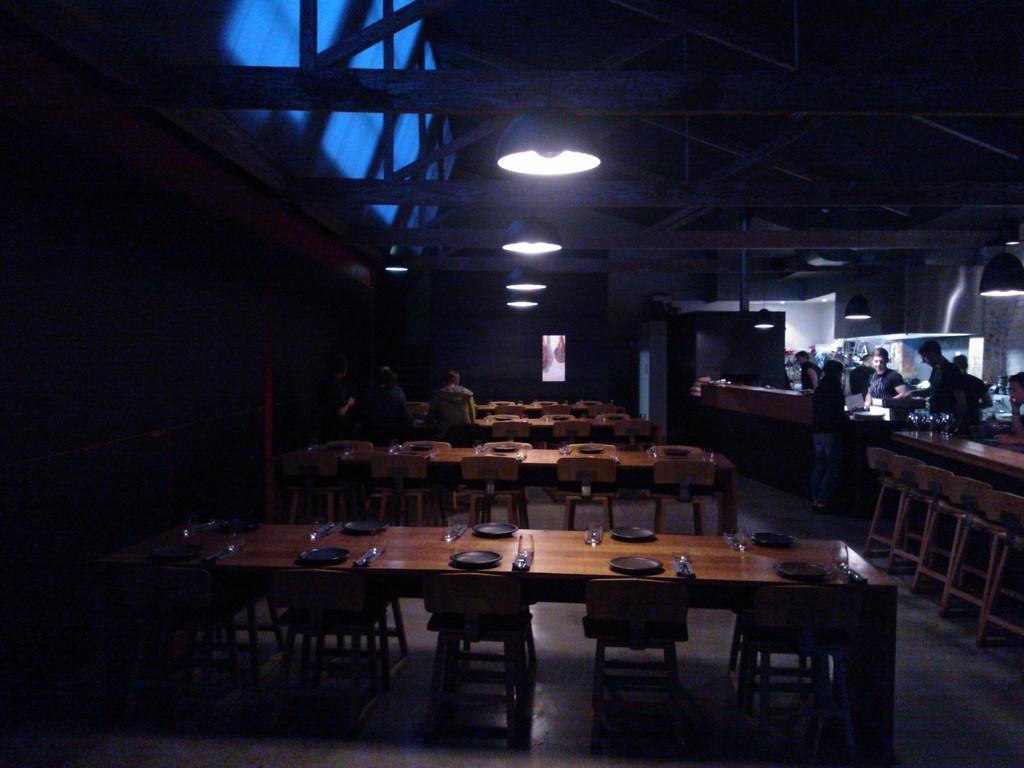Can you describe this image briefly? In this image there are chairs and tables on the floor. Few people are sitting on the chairs. Few people are standing on the floor. On the tables there are plates, glasses and few objects. Few lights are hanging from the roof. Background there is a wall. 